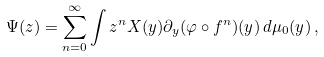Convert formula to latex. <formula><loc_0><loc_0><loc_500><loc_500>\Psi ( z ) = \sum _ { n = 0 } ^ { \infty } \int z ^ { n } X ( y ) { \partial _ { y } } ( \varphi \circ f ^ { n } ) ( y ) \, d \mu _ { 0 } ( y ) \, ,</formula> 